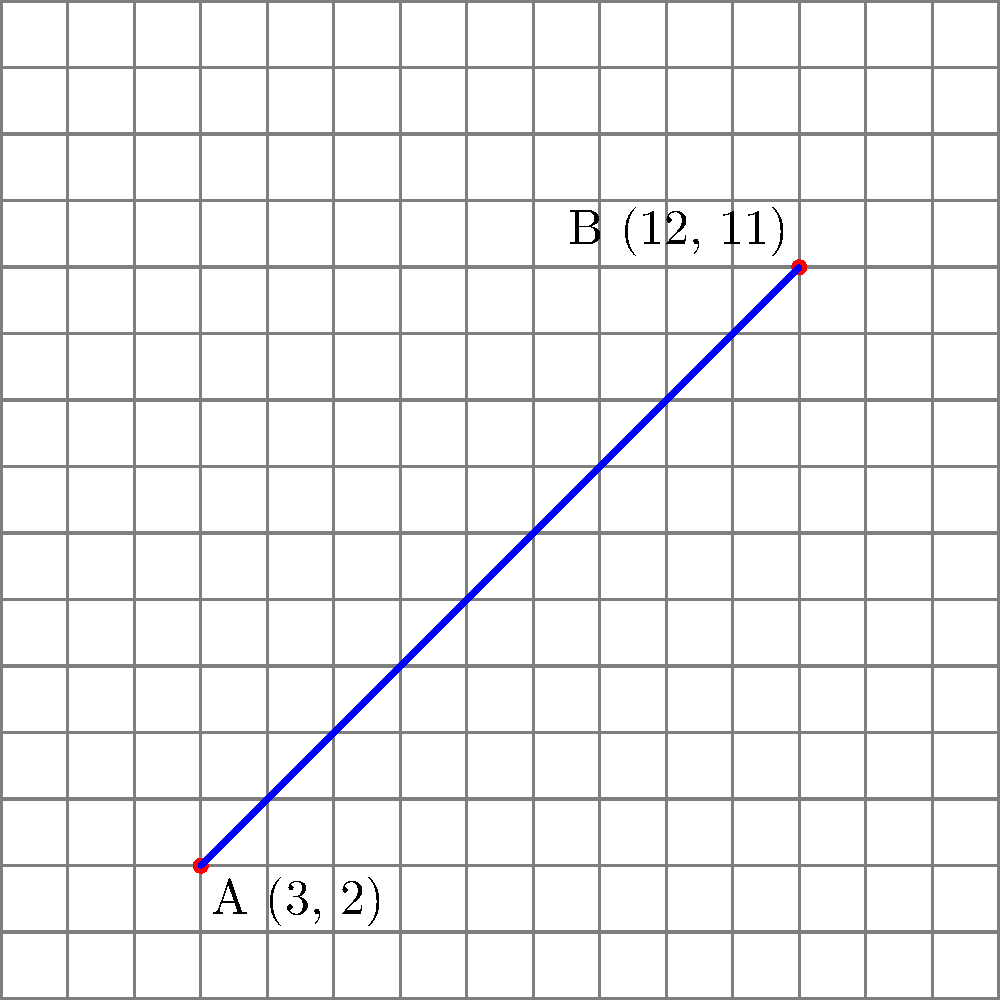On a Scrabble board represented as a 15x15 coordinate grid, two high-scoring word placements are made at points A(3, 2) and B(12, 11). What is the slope of the line connecting these two points? To find the slope of the line connecting two points, we use the slope formula:

$$ m = \frac{y_2 - y_1}{x_2 - x_1} $$

Where $(x_1, y_1)$ represents the coordinates of the first point and $(x_2, y_2)$ represents the coordinates of the second point.

Given:
Point A: $(x_1, y_1) = (3, 2)$
Point B: $(x_2, y_2) = (12, 11)$

Let's substitute these values into the slope formula:

$$ m = \frac{11 - 2}{12 - 3} = \frac{9}{9} = 1 $$

Therefore, the slope of the line connecting the two high-scoring word placements is 1.
Answer: 1 